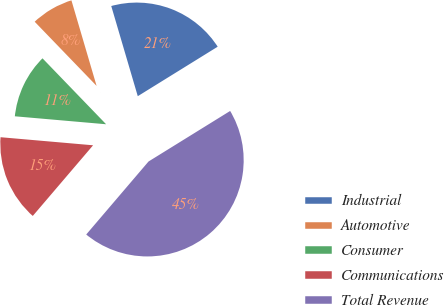Convert chart. <chart><loc_0><loc_0><loc_500><loc_500><pie_chart><fcel>Industrial<fcel>Automotive<fcel>Consumer<fcel>Communications<fcel>Total Revenue<nl><fcel>20.73%<fcel>7.66%<fcel>11.4%<fcel>15.14%<fcel>45.07%<nl></chart> 